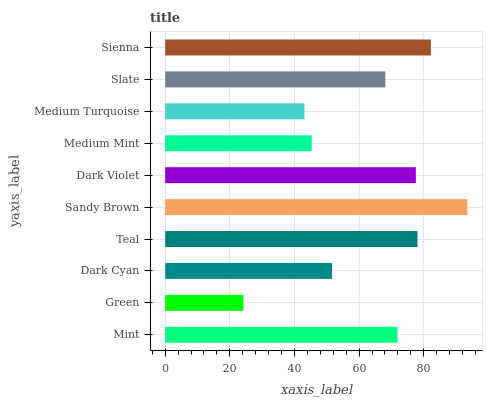Is Green the minimum?
Answer yes or no. Yes. Is Sandy Brown the maximum?
Answer yes or no. Yes. Is Dark Cyan the minimum?
Answer yes or no. No. Is Dark Cyan the maximum?
Answer yes or no. No. Is Dark Cyan greater than Green?
Answer yes or no. Yes. Is Green less than Dark Cyan?
Answer yes or no. Yes. Is Green greater than Dark Cyan?
Answer yes or no. No. Is Dark Cyan less than Green?
Answer yes or no. No. Is Mint the high median?
Answer yes or no. Yes. Is Slate the low median?
Answer yes or no. Yes. Is Green the high median?
Answer yes or no. No. Is Dark Cyan the low median?
Answer yes or no. No. 